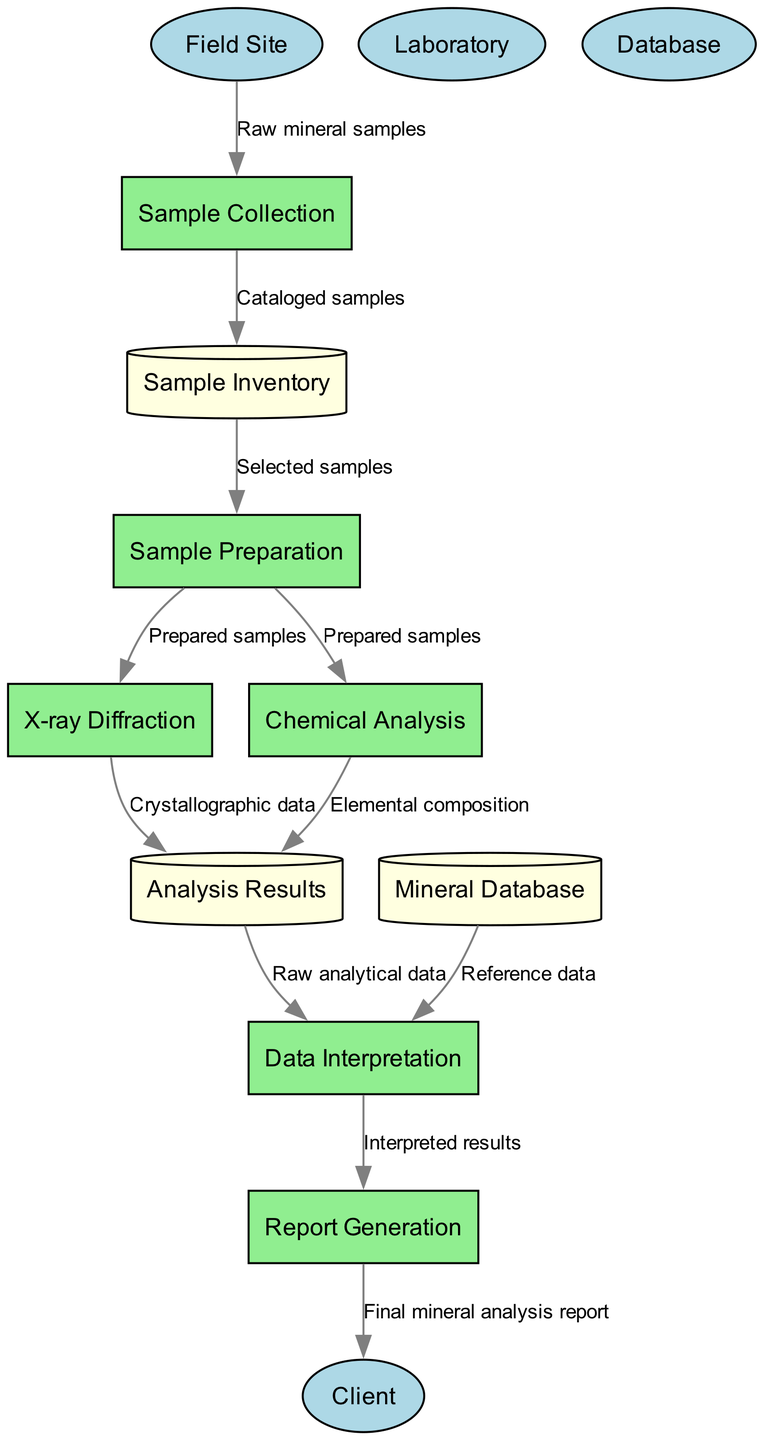What are the external entities in the diagram? The external entities are listed in the diagram as "Field Site", "Laboratory", "Database", and "Client". They represent the sources or recipients of data in the mineral analysis process.
Answer: Field Site, Laboratory, Database, Client How many processes are involved in the mineral analysis process? By counting the processes listed in the diagram, we can see that there are six processes: "Sample Collection", "Sample Preparation", "X-ray Diffraction", "Chemical Analysis", "Data Interpretation", and "Report Generation".
Answer: Six Which process is directly followed by Report Generation? The process that comes right before "Report Generation" in the flow is "Data Interpretation", as shown in the diagram where data flows from Data Interpretation to Report Generation.
Answer: Data Interpretation What data flows from Sample Preparation to X-ray Diffraction? The data flowing from "Sample Preparation" to "X-ray Diffraction" is labeled as "Prepared samples", indicating that the prepared samples are sent onwards for analysis via X-ray Diffraction.
Answer: Prepared samples What type of data is generated by Chemical Analysis? According to the diagram, Chemical Analysis generates "Elemental composition" as its output, as indicated by the arrow connecting Chemical Analysis to the Analysis Results data store.
Answer: Elemental composition How does the Mineral Database contribute to Data Interpretation? The Mineral Database provides "Reference data" to the Data Interpretation process, which is necessary for interpreting the analytical results. This relationship is illustrated by the arrow from Mineral Database to Data Interpretation.
Answer: Reference data Which entity receives the final mineral analysis report? The final mineral analysis report is sent to the "Client" as shown by the arrow linking Report Generation to the Client, indicating that the report is the final output of the process.
Answer: Client How many data stores are there in the diagram? The diagram includes three data stores: "Sample Inventory", "Mineral Database", and "Analysis Results". Counting them confirms this total.
Answer: Three What is the first process in the mineral analysis flow? The first process in the flow of the diagram is "Sample Collection", as it is the initial step that begins with receiving raw mineral samples from the Field Site.
Answer: Sample Collection 